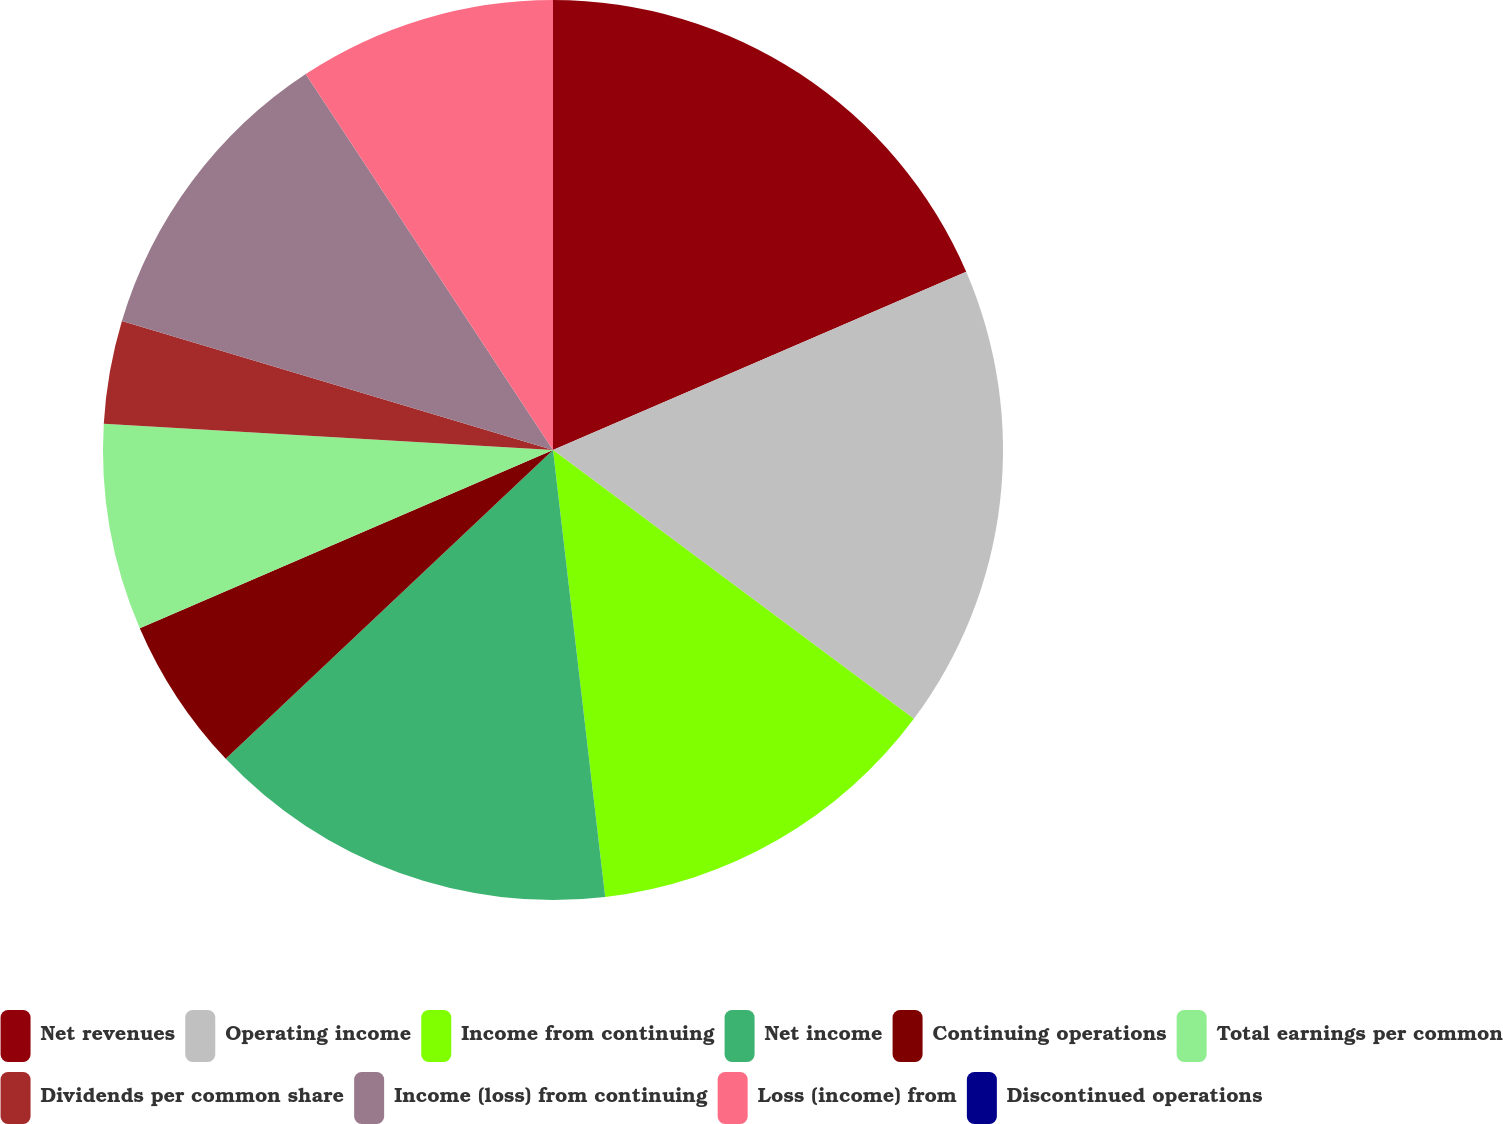Convert chart. <chart><loc_0><loc_0><loc_500><loc_500><pie_chart><fcel>Net revenues<fcel>Operating income<fcel>Income from continuing<fcel>Net income<fcel>Continuing operations<fcel>Total earnings per common<fcel>Dividends per common share<fcel>Income (loss) from continuing<fcel>Loss (income) from<fcel>Discontinued operations<nl><fcel>18.52%<fcel>16.67%<fcel>12.96%<fcel>14.81%<fcel>5.56%<fcel>7.41%<fcel>3.7%<fcel>11.11%<fcel>9.26%<fcel>0.0%<nl></chart> 